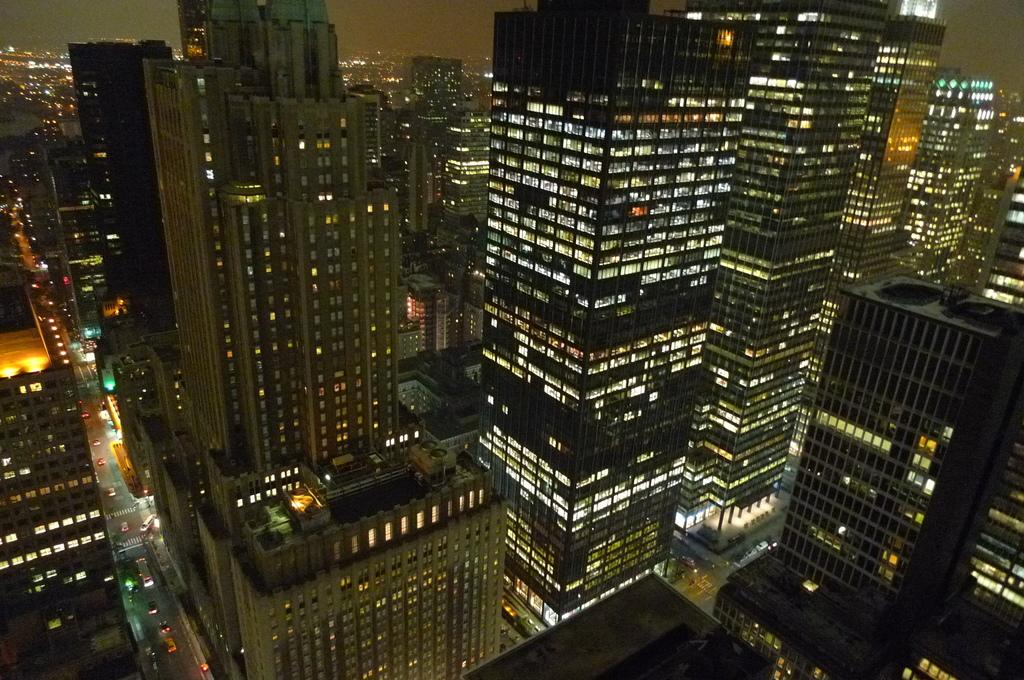What type of structures can be seen in the image? There are buildings in the image. Are there any specific features of the buildings that can be observed? Yes, there are lights in the buildings. What type of bushes can be seen growing around the buildings in the image? There is no mention of bushes in the provided facts, so we cannot determine if they are present in the image. 